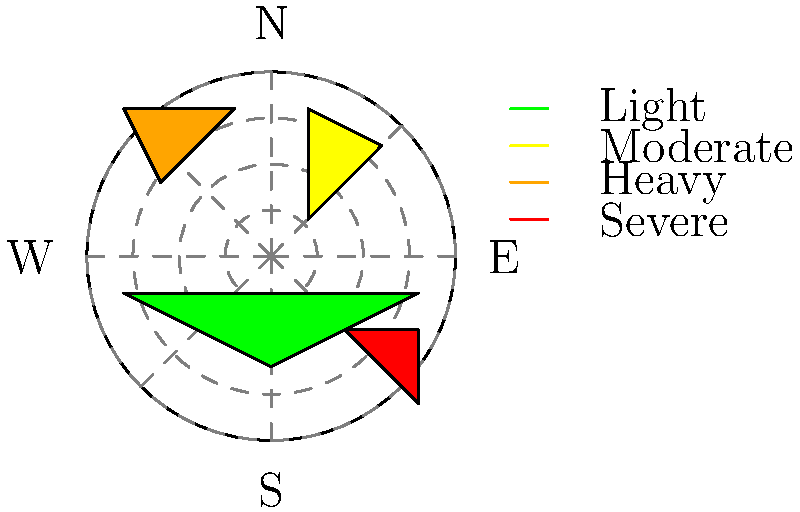As a newly licensed pilot planning a flight from west to east, you encounter this complex weather radar image. Which of the following flight paths would be the safest option to avoid severe weather conditions?

A) Flying directly from west to east
B) Taking a slight detour to the southwest before heading east
C) Flying northwest and then northeast
D) Flying southwest and then southeast To interpret this complex weather radar imagery for flight planning, let's analyze the image step-by-step:

1. Orientation: The radar image shows a circular view with cardinal directions marked (N, S, E, W).

2. Color coding: The legend indicates severity levels:
   - Green: Light precipitation
   - Yellow: Moderate precipitation
   - Orange: Heavy precipitation
   - Red: Severe weather conditions

3. Weather pattern analysis:
   - West: Relatively clear, with some light precipitation (green)
   - Southwest: Severe weather (red patch)
   - South: Mostly clear
   - Southeast: Light precipitation (green)
   - East: Moderate precipitation (yellow)
   - Northeast: Heavy precipitation (orange)
   - North: Mostly clear
   - Northwest: Clear

4. Flight path options:
   A) Flying directly west to east: This path encounters moderate precipitation (yellow) and is close to heavy precipitation (orange).
   B) Southwest then east: This route goes through severe weather conditions (red), which is extremely dangerous.
   C) Northwest then northeast: This path initially avoids all precipitation but then encounters heavy precipitation (orange).
   D) Southwest then southeast: This route avoids the severe weather (red) and only encounters light precipitation (green).

5. Safety considerations: As a newly licensed pilot, it's crucial to prioritize safety and avoid severe weather conditions. The safest route would be one that minimizes exposure to precipitation, especially heavy and severe weather.

Considering all factors, option D (flying southwest and then southeast) provides the safest path. It avoids the severe weather in the southwest by flying around it and only encounters light precipitation, which is generally safe for flight operations.
Answer: D) Flying southwest and then southeast 